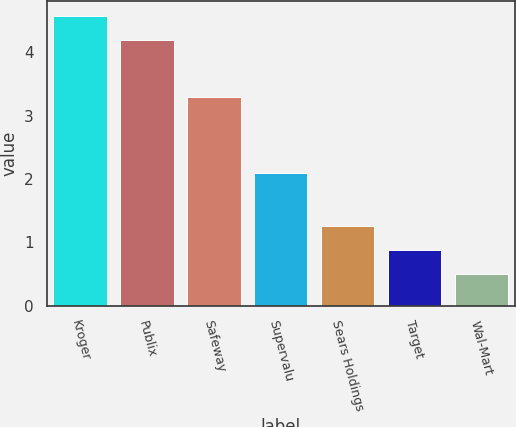Convert chart to OTSL. <chart><loc_0><loc_0><loc_500><loc_500><bar_chart><fcel>Kroger<fcel>Publix<fcel>Safeway<fcel>Supervalu<fcel>Sears Holdings<fcel>Target<fcel>Wal-Mart<nl><fcel>4.58<fcel>4.2<fcel>3.3<fcel>2.1<fcel>1.26<fcel>0.88<fcel>0.5<nl></chart> 